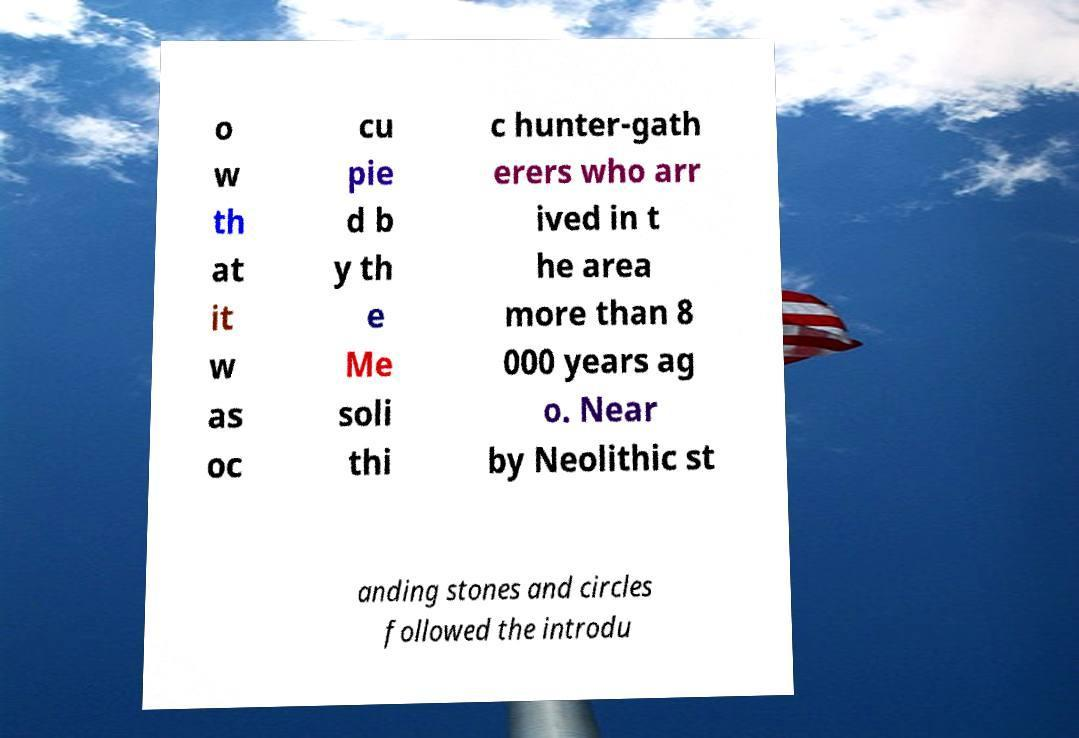There's text embedded in this image that I need extracted. Can you transcribe it verbatim? o w th at it w as oc cu pie d b y th e Me soli thi c hunter-gath erers who arr ived in t he area more than 8 000 years ag o. Near by Neolithic st anding stones and circles followed the introdu 